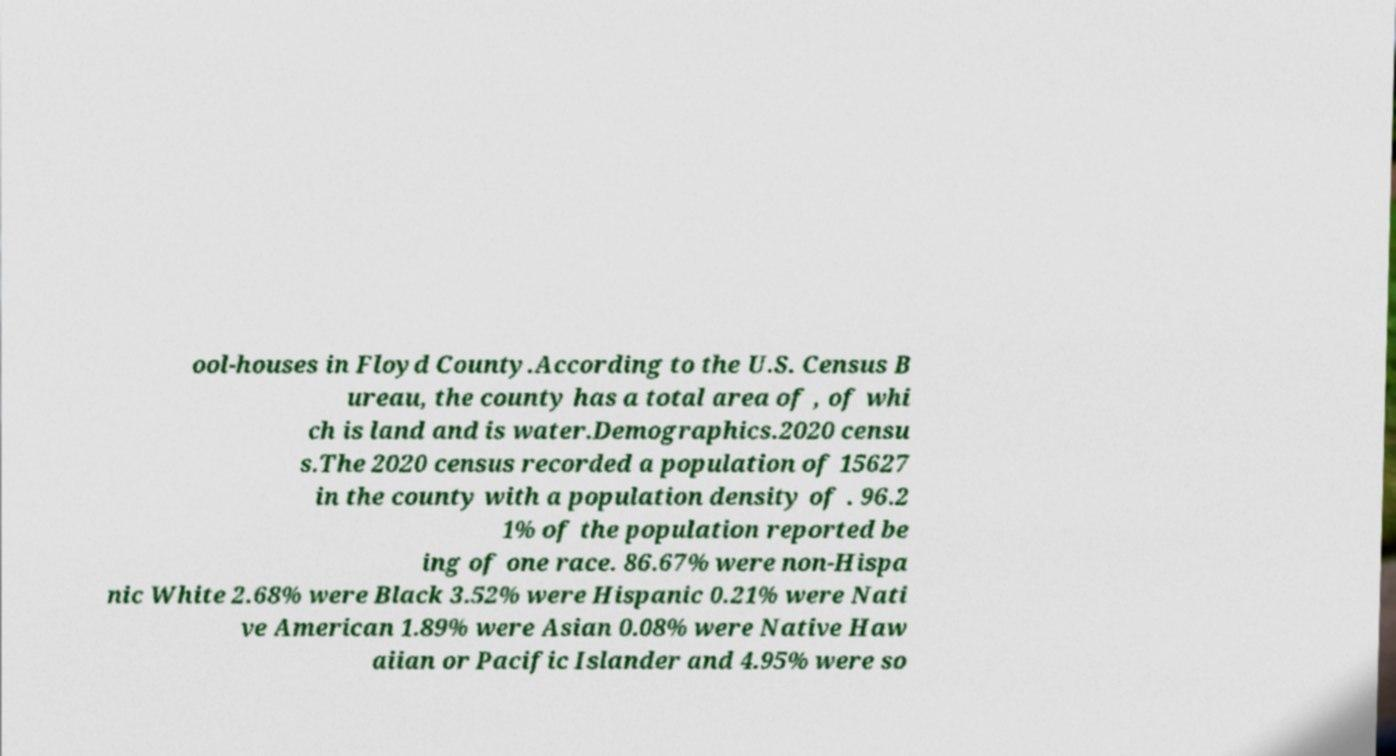Could you extract and type out the text from this image? ool-houses in Floyd County.According to the U.S. Census B ureau, the county has a total area of , of whi ch is land and is water.Demographics.2020 censu s.The 2020 census recorded a population of 15627 in the county with a population density of . 96.2 1% of the population reported be ing of one race. 86.67% were non-Hispa nic White 2.68% were Black 3.52% were Hispanic 0.21% were Nati ve American 1.89% were Asian 0.08% were Native Haw aiian or Pacific Islander and 4.95% were so 